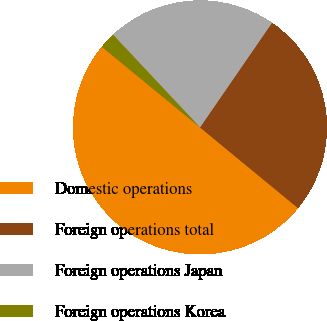<chart> <loc_0><loc_0><loc_500><loc_500><pie_chart><fcel>Domestic operations<fcel>Foreign operations total<fcel>Foreign operations Japan<fcel>Foreign operations Korea<nl><fcel>49.97%<fcel>26.37%<fcel>21.58%<fcel>2.07%<nl></chart> 